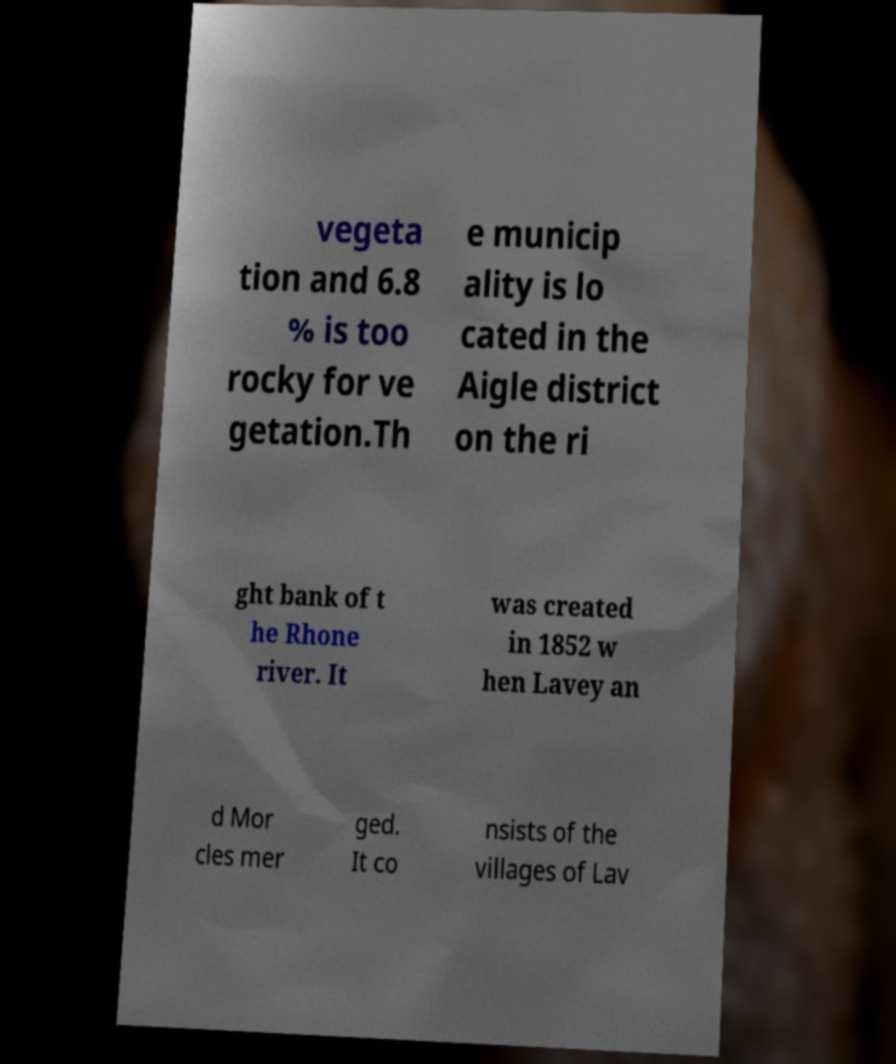Please identify and transcribe the text found in this image. vegeta tion and 6.8 % is too rocky for ve getation.Th e municip ality is lo cated in the Aigle district on the ri ght bank of t he Rhone river. It was created in 1852 w hen Lavey an d Mor cles mer ged. It co nsists of the villages of Lav 